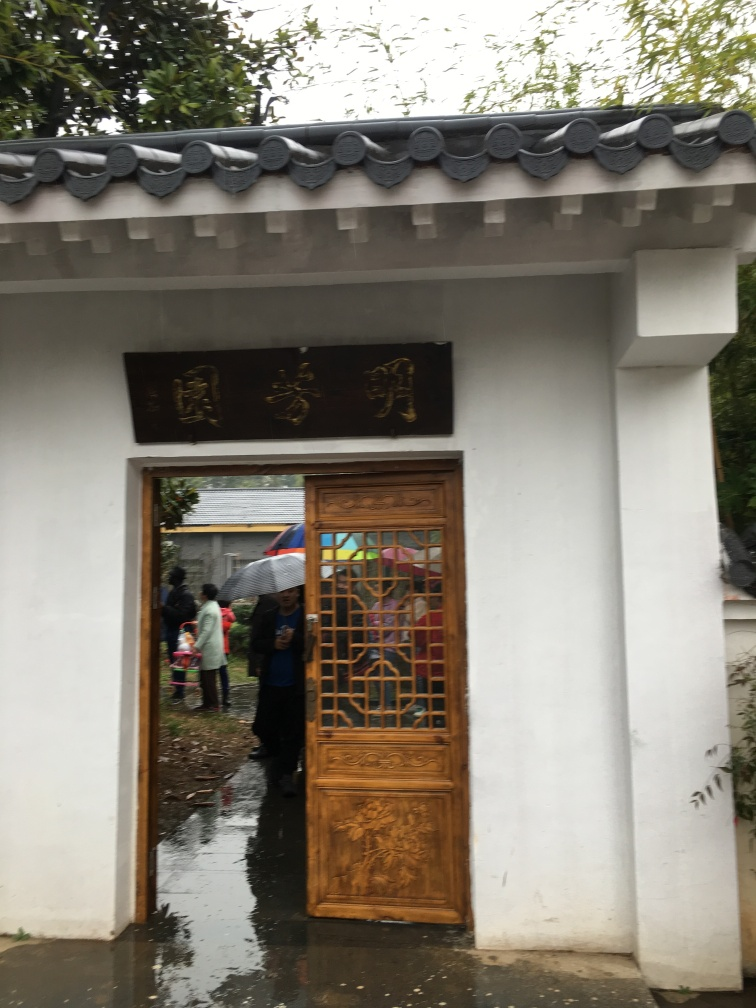Can you tell me about the weather conditions in this image? The ground appears wet, reflecting what might be a rainy day, and several persons are carrying umbrellas, suggesting recent or ongoing rain. 